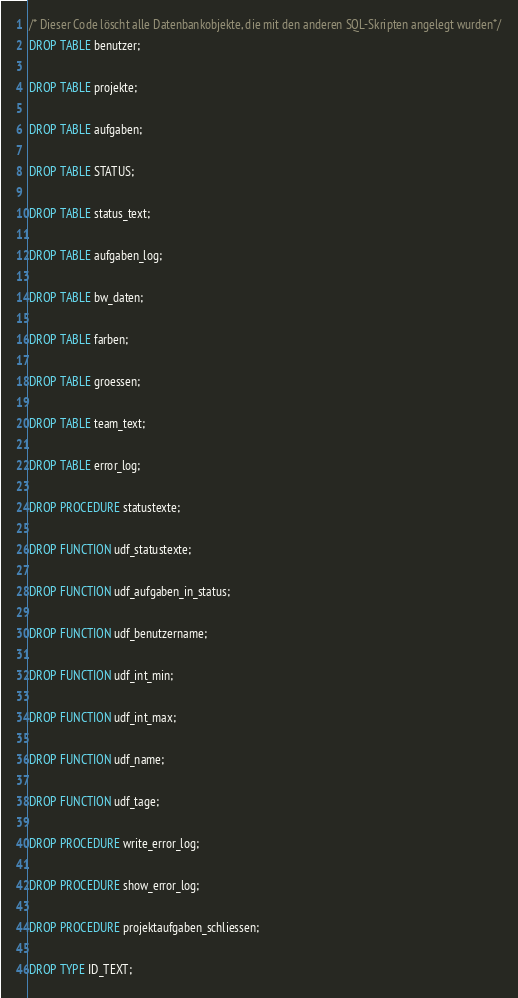Convert code to text. <code><loc_0><loc_0><loc_500><loc_500><_SQL_>/* Dieser Code löscht alle Datenbankobjekte, die mit den anderen SQL-Skripten angelegt wurden*/
DROP TABLE benutzer;

DROP TABLE projekte;

DROP TABLE aufgaben;

DROP TABLE STATUS;

DROP TABLE status_text;

DROP TABLE aufgaben_log;

DROP TABLE bw_daten;

DROP TABLE farben;

DROP TABLE groessen;

DROP TABLE team_text;

DROP TABLE error_log;

DROP PROCEDURE statustexte;

DROP FUNCTION udf_statustexte;

DROP FUNCTION udf_aufgaben_in_status;

DROP FUNCTION udf_benutzername;

DROP FUNCTION udf_int_min;

DROP FUNCTION udf_int_max;

DROP FUNCTION udf_name;

DROP FUNCTION udf_tage;

DROP PROCEDURE write_error_log;

DROP PROCEDURE show_error_log;

DROP PROCEDURE projektaufgaben_schliessen;

DROP TYPE ID_TEXT;
</code> 